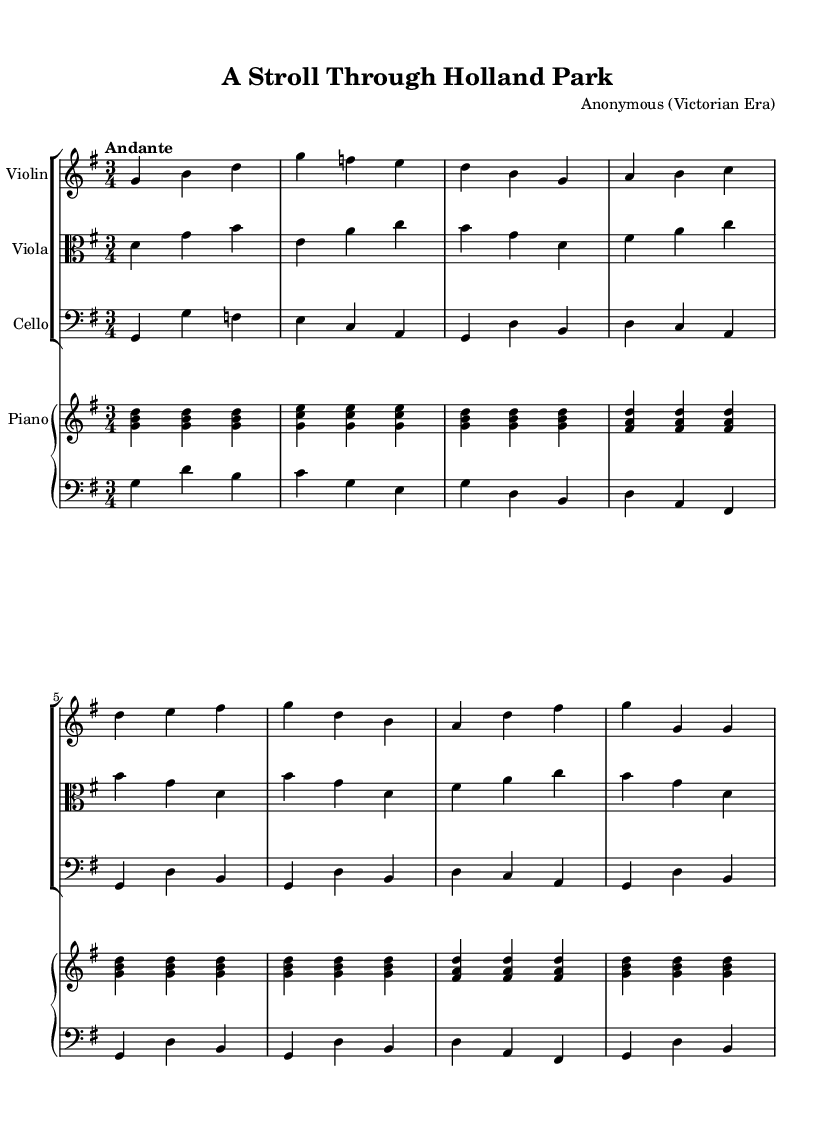What is the key signature of this music? The key signature is G major, which has one sharp (F#). In the music sheet, the sharp is indicated at the beginning, confirming that the piece is in G major.
Answer: G major What is the time signature of the piece? The time signature is 3/4, indicating that there are three beats in each measure and the quarter note receives one beat. This can be seen at the beginning of the score, right next to the key signature.
Answer: 3/4 What is the tempo marking for this piece? The tempo marking is "Andante," suggesting a moderate pace. The marking is indicated at the beginning of the score, guiding the overall feel of the piece.
Answer: Andante How many measures are in the A section? The A section contains 8 measures. This can be determined by counting the measures within the section specifically noted for the A section in the violin, viola, cello, and piano parts, which is defined to be the first 8 bars after the introduction.
Answer: 8 measures What instruments are featured in this chamber music? The instruments featured are Violin, Viola, Cello, and Piano. This is highlighted at the top of each staff in the score, identifying the specific parts meant for each instrument.
Answer: Violin, Viola, Cello, Piano What was the role of the cello in this composition? The role of the cello is to provide a simplified bass line and accompaniment for the piece. This is observable in the rhythmic and harmonic function of the cello part, which focuses on the foundational notes that support the harmony throughout.
Answer: Bass line What is a common characteristic of Victorian-era chamber music reflected in this piece? A common characteristic is the use of rich harmonies and elegant melodies. This can be inferred from the melodic structure and chord progressions throughout the piece, which echo the musical aesthetics typical of the Victorian era.
Answer: Rich harmonies 